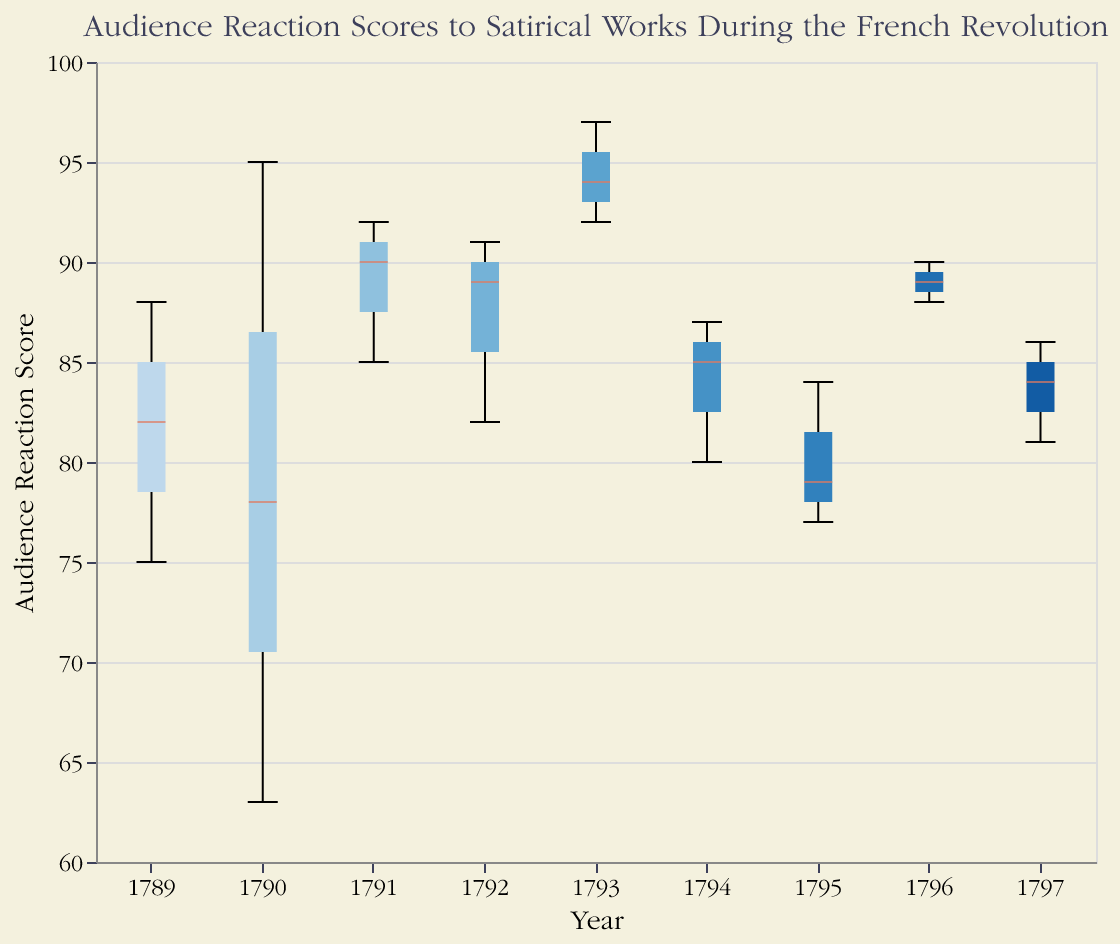What is the title of the plot? The title of the plot is located at the top and indicates what the plot is about.
Answer: Audience Reaction Scores to Satirical Works During the French Revolution Which year has the highest median audience reaction score? Look at the middle lines within the boxes (which represent the medians) and determine the highest one.
Answer: 1793 How many years are displayed on the x-axis? Count the distinct labels on the x-axis
Answer: 9 What is the median audience reaction score for the year 1794? Locate the median line within the box for 1794 on the y-axis.
Answer: 85 Which year has the widest range of audience reaction scores? The boxplot with the longest vertical span between its lower and upper whiskers indicates the widest range.
Answer: 1790 Compare the audience reaction scores of 1791 and 1793. Which year had generally higher audience reaction scores? By examining the median lines and overall spread of boxes for 1791 and 1793
Answer: 1793 Between which years do you observe a clear increase in the median audience reaction score? Locate the successive years on the x-axis and observe the vertical positions of the median lines.
Answer: 1792 to 1793 What is the interquartile range (IQR) of audience reaction scores for the year 1790? The IQR is the difference between the third quartile (top of the box) and the first quartile (bottom of the box) for 1790. Estimate these positions from the plot on the y-axis.
Answer: 78 - 66 = 12 Was there any year where all satirical works had reaction scores above 80? Determine if the lowest point (bottom whisker) of any year's boxplot remains above 80.
Answer: 1793 By how much does the median audience reaction score in 1795 differ from that in 1796? Compute the absolute difference between the medians of 1795 and 1796 by examining their median lines on the y-axis.
Answer: 6 